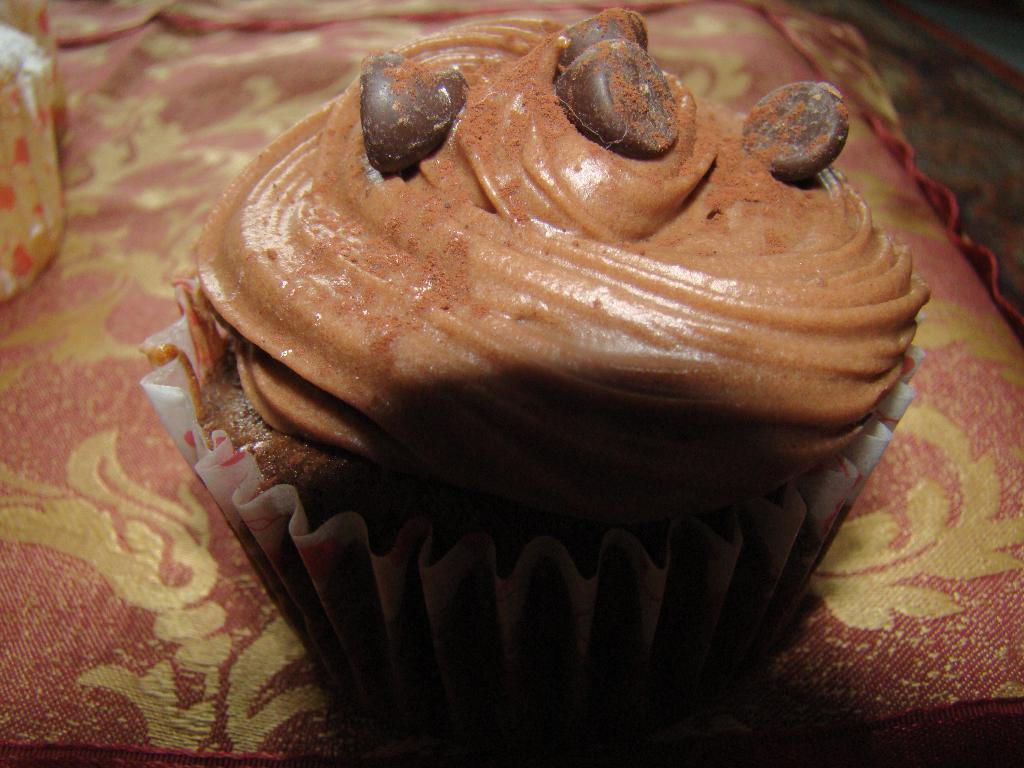What type of dessert is in the image? There is a cupcake in the image. How is the cupcake contained? The cupcake is in a cupcake paper. What is the appearance of the cupcake's frosting? The cupcake has cream frosting. Are there any additional toppings on the cupcake? Yes, there are chocolate chips on the cream frosting. What can be seen at the bottom of the image? There is a cloth visible at the bottom of the image. What type of bone is visible in the image? There is no bone present in the image; it features a cupcake with cream frosting and chocolate chips. What decision is the committee making in the image? There is no committee or decision-making process depicted in the image; it focuses on a cupcake. 